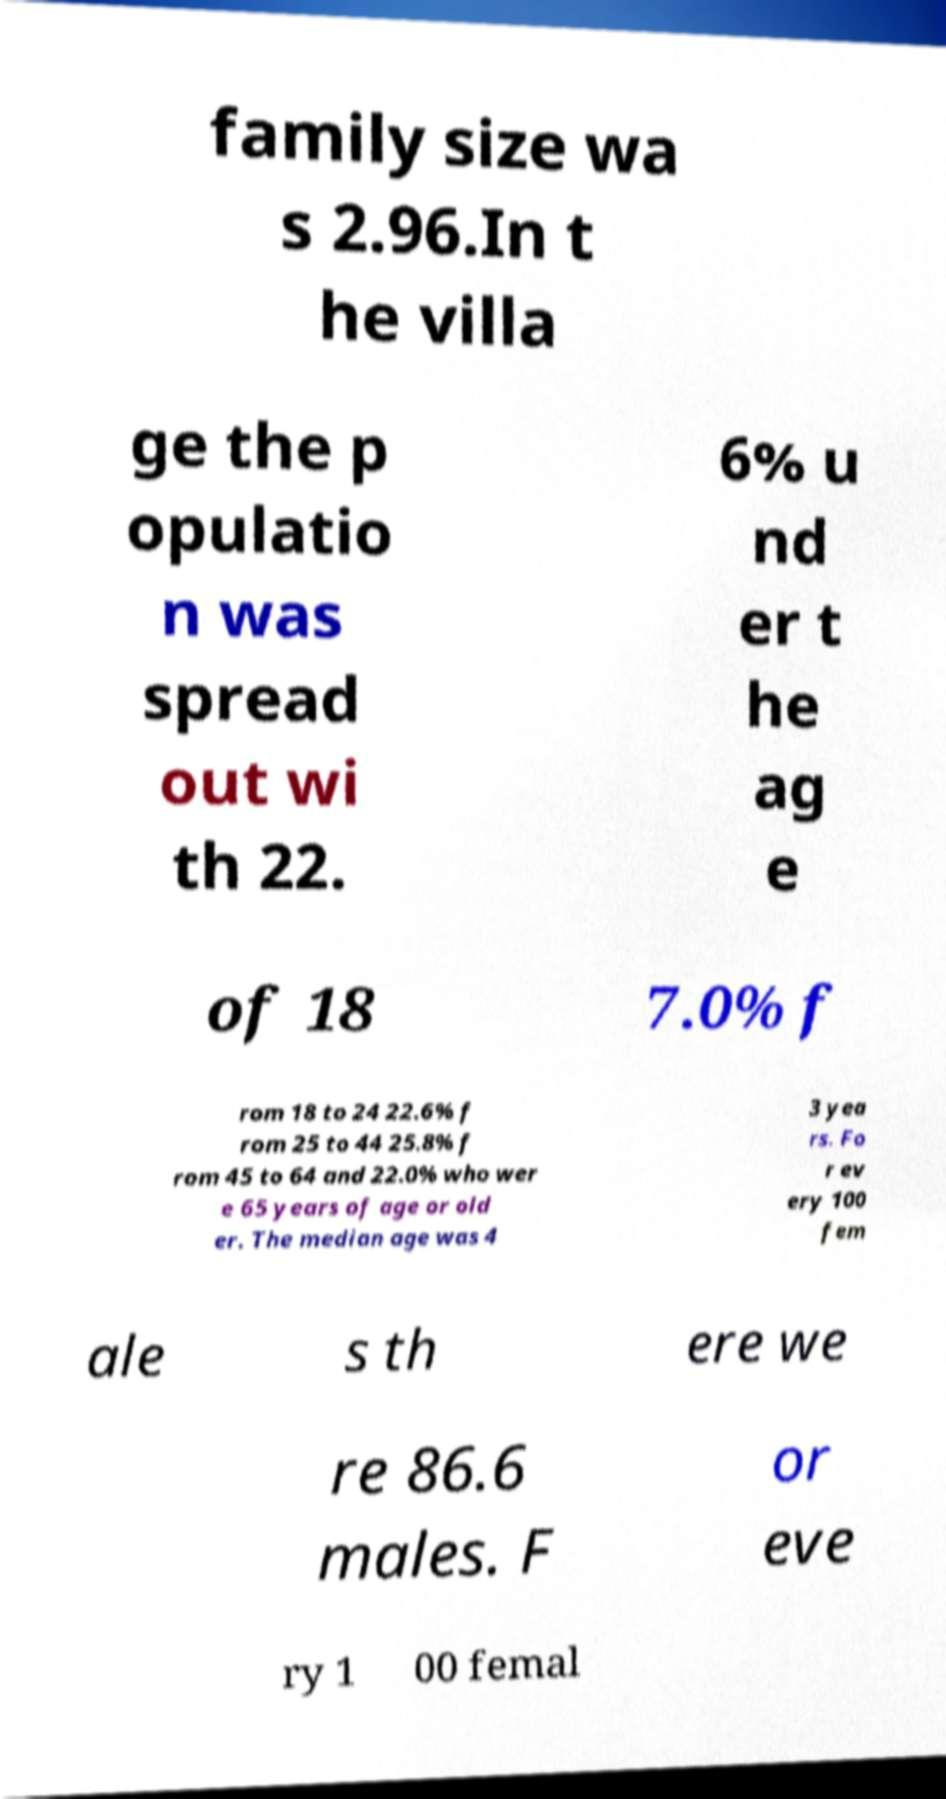I need the written content from this picture converted into text. Can you do that? family size wa s 2.96.In t he villa ge the p opulatio n was spread out wi th 22. 6% u nd er t he ag e of 18 7.0% f rom 18 to 24 22.6% f rom 25 to 44 25.8% f rom 45 to 64 and 22.0% who wer e 65 years of age or old er. The median age was 4 3 yea rs. Fo r ev ery 100 fem ale s th ere we re 86.6 males. F or eve ry 1 00 femal 